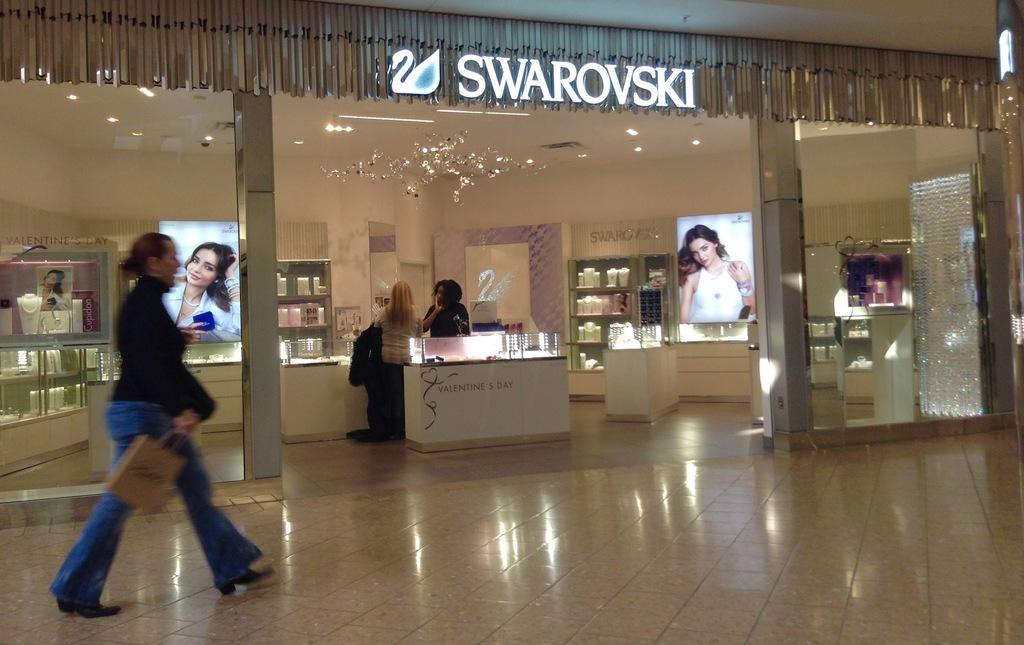How many people are in the image? There are people in the image, but the exact number is not specified. What type of flooring is present in the image? The floor is tiled. What kind of establishment is depicted in the image? There is a store in the image. What objects are present in the image that are used for storage? There are boards and cupboards in the image. What type of furniture is present in the image? There are tables in the image. What type of lighting is present in the image? There are lights in the image. What can be inferred about the image based on the presence of various things? The image contains a variety of objects and items. What is one person in the image doing? One person is walking and holding a bag. What type of quilt is being used by the sister in the image? There is no mention of a sister or a quilt in the image or the provided facts. 